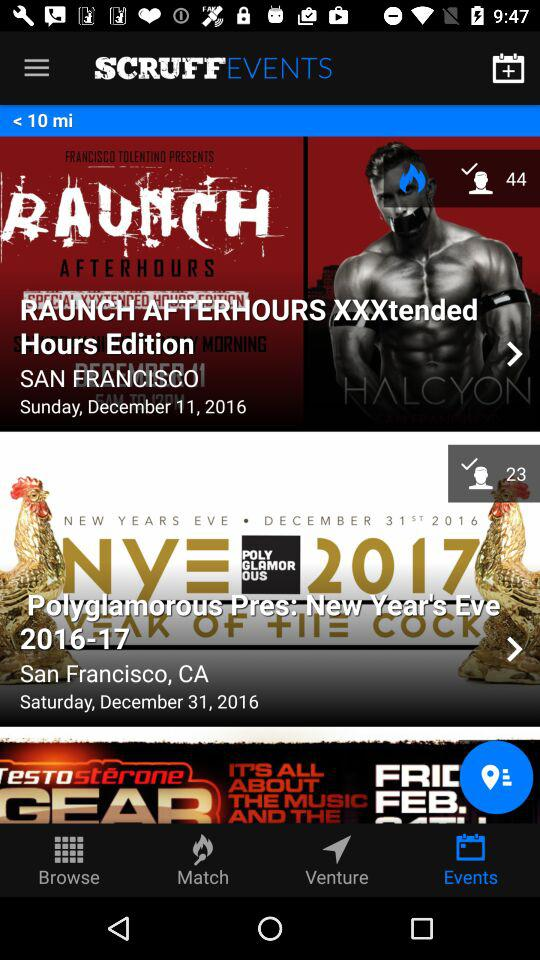Which tab is selected? The selected tab is "Events". 